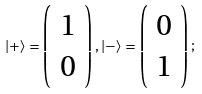Convert formula to latex. <formula><loc_0><loc_0><loc_500><loc_500>| + \rangle = \left ( \begin{array} { c } 1 \\ 0 \end{array} \right ) , | - \rangle = \left ( \begin{array} { c } 0 \\ 1 \end{array} \right ) ;</formula> 